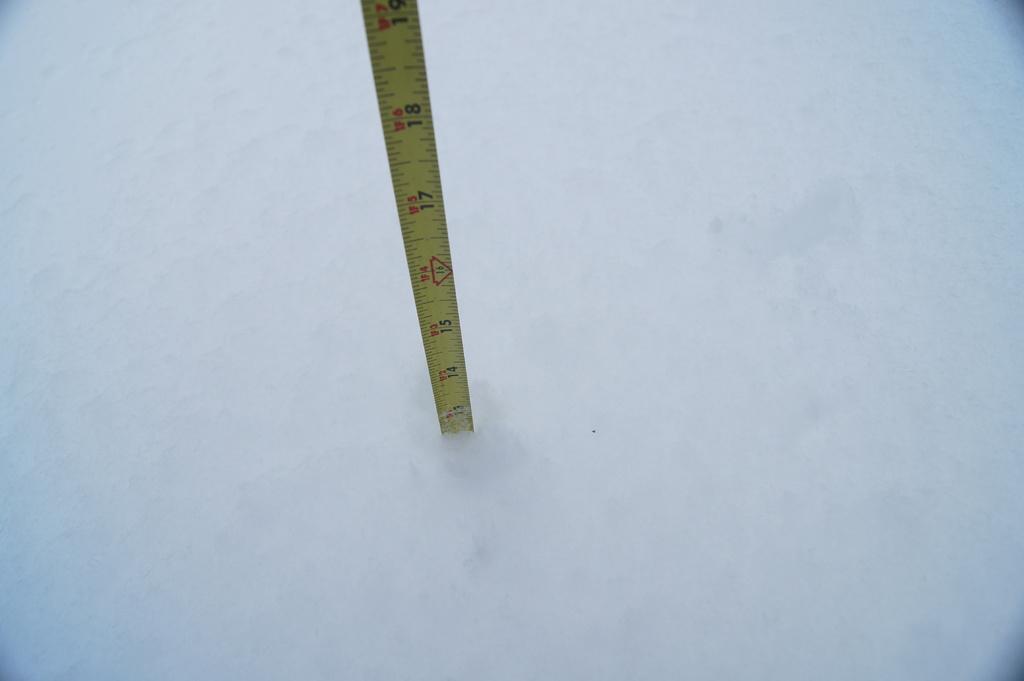In one or two sentences, can you explain what this image depicts? In this image I can see the white colored object and a measuring tape which is yellow, red and black in color is inserted in the white colored object. 